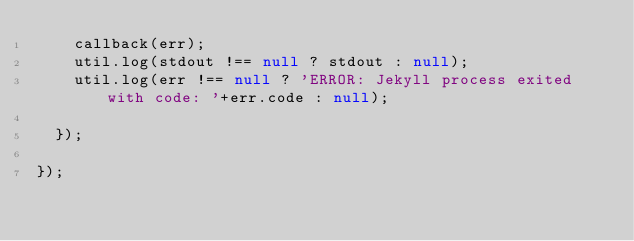<code> <loc_0><loc_0><loc_500><loc_500><_JavaScript_>		callback(err);
		util.log(stdout !== null ? stdout : null);
		util.log(err !== null ? 'ERROR: Jekyll process exited with code: '+err.code : null);

	});

});</code> 